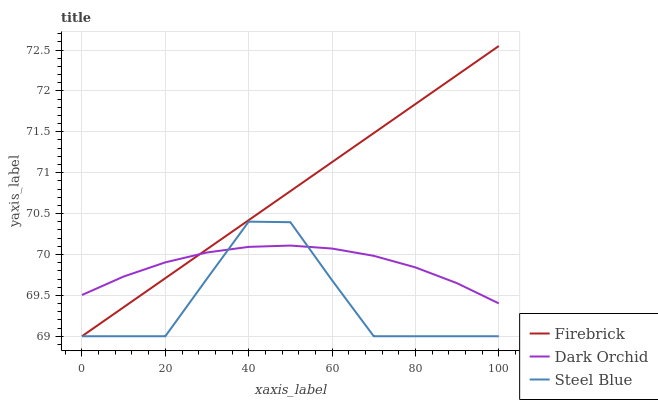Does Steel Blue have the minimum area under the curve?
Answer yes or no. Yes. Does Firebrick have the maximum area under the curve?
Answer yes or no. Yes. Does Dark Orchid have the minimum area under the curve?
Answer yes or no. No. Does Dark Orchid have the maximum area under the curve?
Answer yes or no. No. Is Firebrick the smoothest?
Answer yes or no. Yes. Is Steel Blue the roughest?
Answer yes or no. Yes. Is Dark Orchid the smoothest?
Answer yes or no. No. Is Dark Orchid the roughest?
Answer yes or no. No. Does Firebrick have the lowest value?
Answer yes or no. Yes. Does Dark Orchid have the lowest value?
Answer yes or no. No. Does Firebrick have the highest value?
Answer yes or no. Yes. Does Steel Blue have the highest value?
Answer yes or no. No. Does Dark Orchid intersect Firebrick?
Answer yes or no. Yes. Is Dark Orchid less than Firebrick?
Answer yes or no. No. Is Dark Orchid greater than Firebrick?
Answer yes or no. No. 